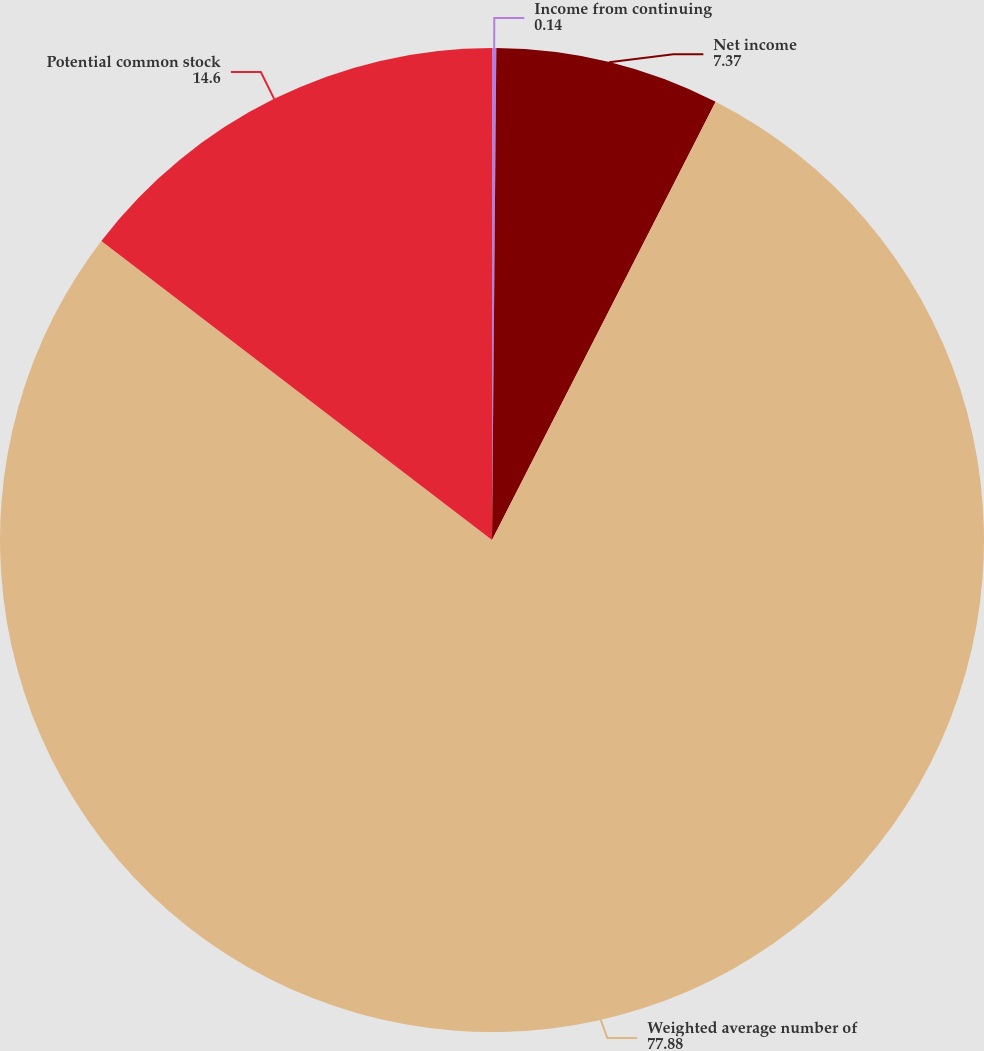Convert chart to OTSL. <chart><loc_0><loc_0><loc_500><loc_500><pie_chart><fcel>Income from continuing<fcel>Net income<fcel>Weighted average number of<fcel>Potential common stock<nl><fcel>0.14%<fcel>7.37%<fcel>77.88%<fcel>14.6%<nl></chart> 